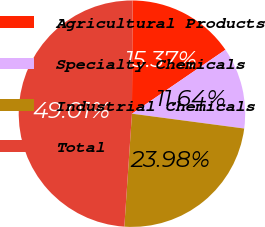Convert chart to OTSL. <chart><loc_0><loc_0><loc_500><loc_500><pie_chart><fcel>Agricultural Products<fcel>Specialty Chemicals<fcel>Industrial Chemicals<fcel>Total<nl><fcel>15.37%<fcel>11.64%<fcel>23.98%<fcel>49.01%<nl></chart> 